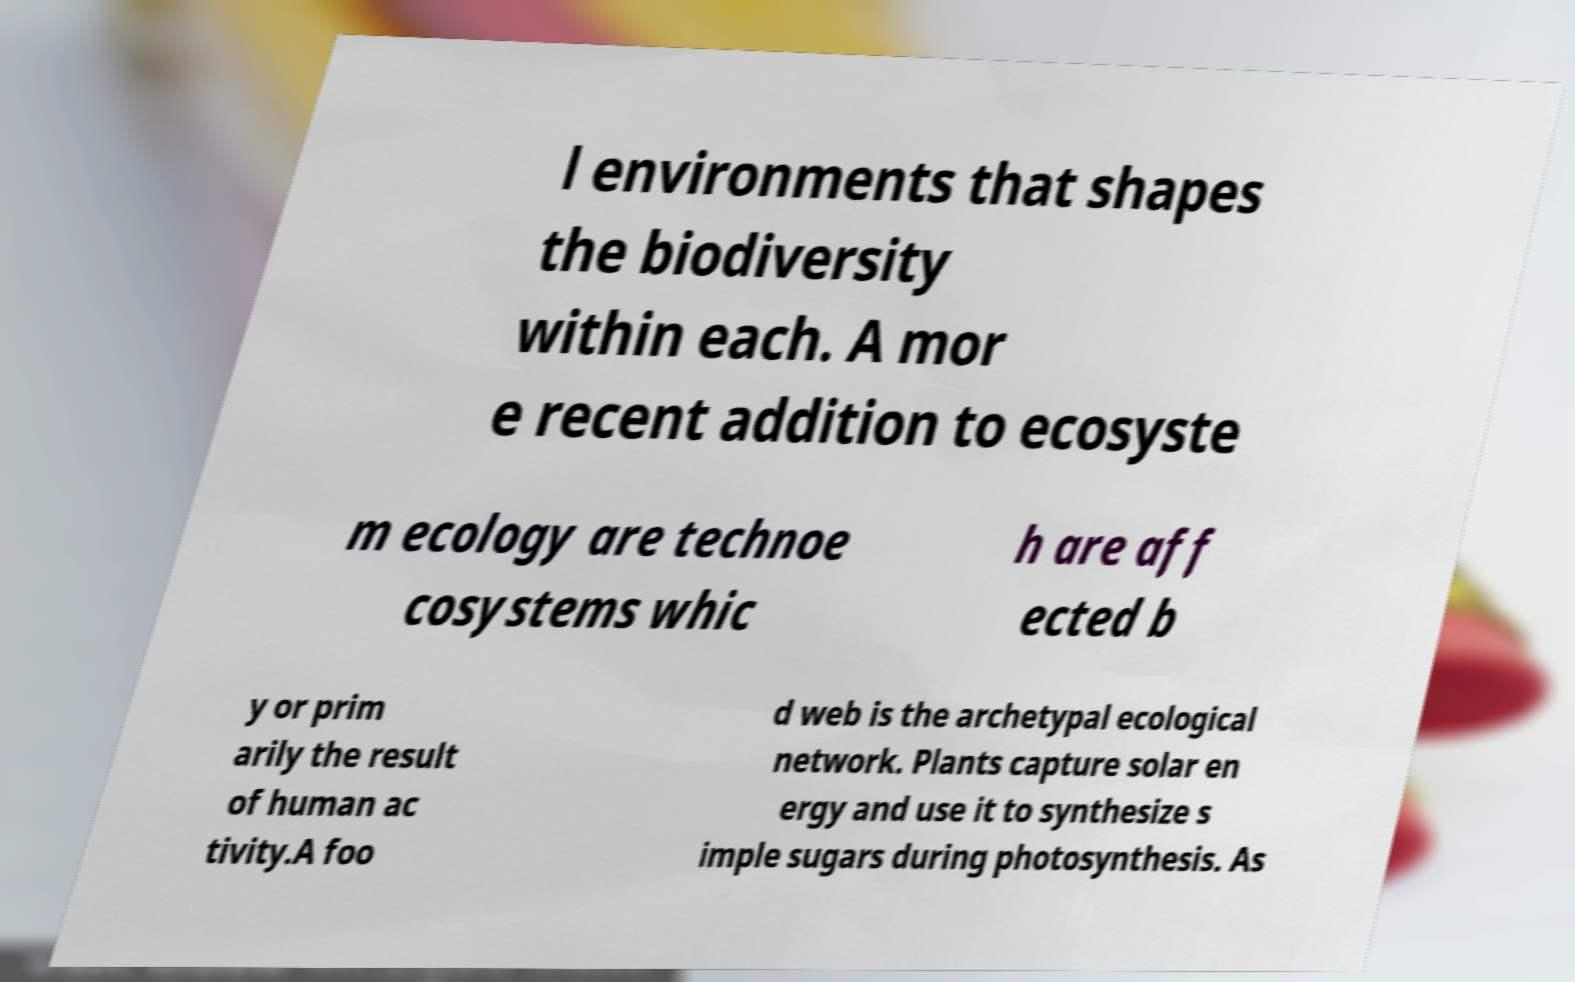What messages or text are displayed in this image? I need them in a readable, typed format. l environments that shapes the biodiversity within each. A mor e recent addition to ecosyste m ecology are technoe cosystems whic h are aff ected b y or prim arily the result of human ac tivity.A foo d web is the archetypal ecological network. Plants capture solar en ergy and use it to synthesize s imple sugars during photosynthesis. As 